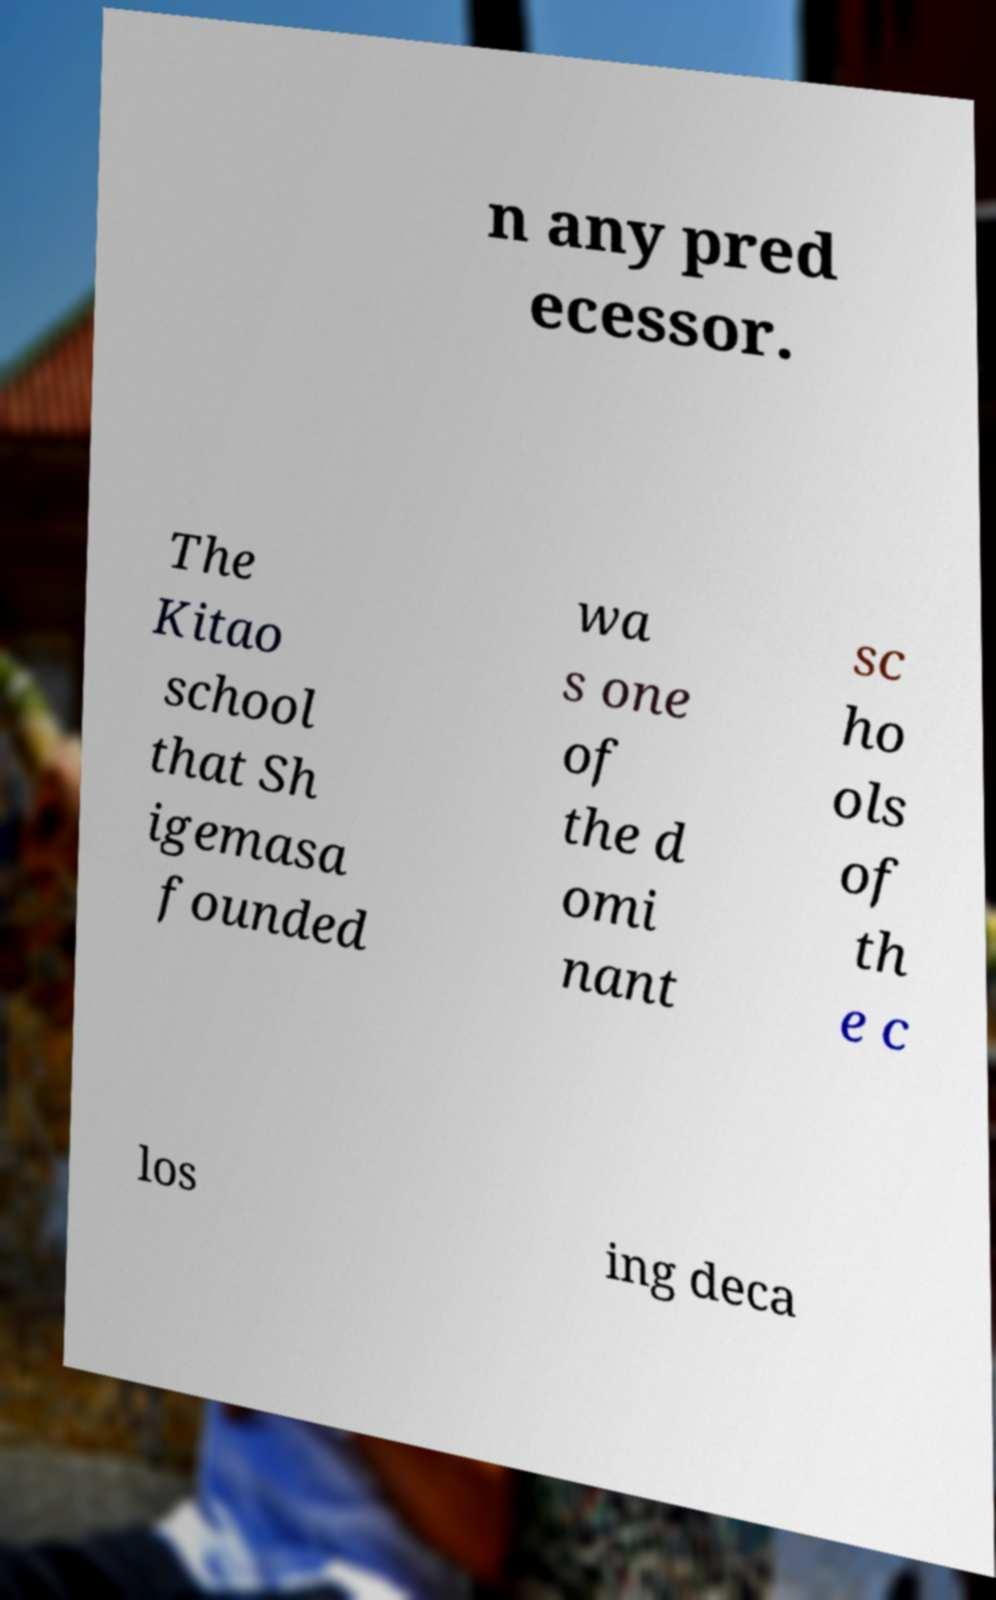I need the written content from this picture converted into text. Can you do that? n any pred ecessor. The Kitao school that Sh igemasa founded wa s one of the d omi nant sc ho ols of th e c los ing deca 